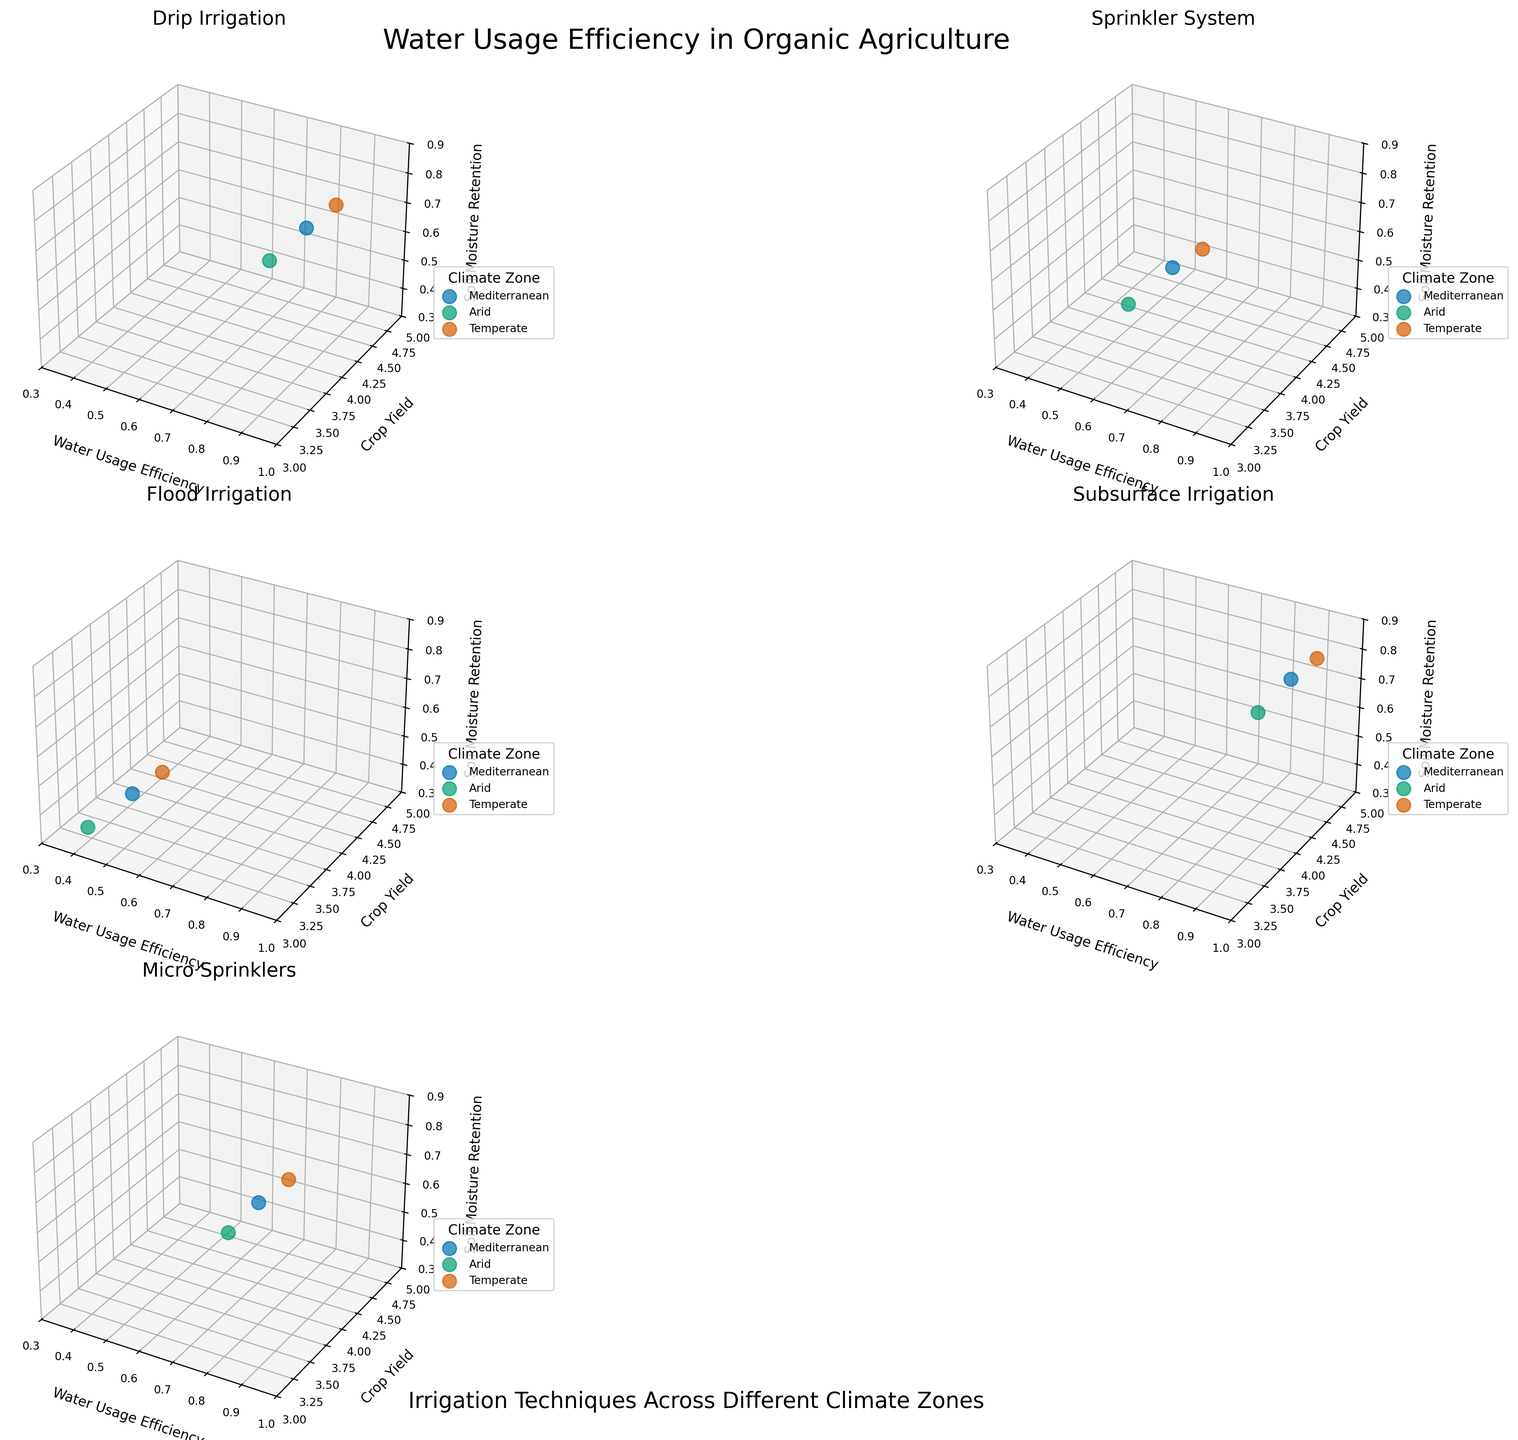What is the title of the overall plot? The overall plot title is positioned at the top-center of the figure and reads "Water Usage Efficiency in Organic Agriculture".
Answer: Water Usage Efficiency in Organic Agriculture Which irrigation technique shows the highest water usage efficiency? By comparing the water usage efficiency values along the x-axis in each subplot, the "Subsurface Irrigation" technique consistently shows the highest values, above 0.85 across all climate zones.
Answer: Subsurface Irrigation How many climate zones are represented in each subplot and what are they? Each subplot includes multiple colored markers, each representing a different climate zone. The legend indicates that the zones are "Mediterranean", "Arid", and "Temperate".
Answer: Three climate zones: Mediterranean, Arid, Temperate For the "Drip Irrigation" technique, which climate zone has the highest soil moisture retention? In the "Drip Irrigation" subplot, soil moisture retention values are indicated along the z-axis. The highest values are observed in the "Temperate" zone (0.75).
Answer: Temperate Compare the crop yield in the "Flood Irrigation" subplot across all climate zones. Which zone has the lowest value? The crop yields for "Flood Irrigation" are indicated along the y-axis. The "Arid" climate zone shows the lowest value with a yield of about 3.2.
Answer: Arid Which irrigation technique has the lowest water usage efficiency in the "Arid" climate zone? By examining the "Arid" points across all subplots, "Flood Irrigation" has the lowest water usage efficiency, with a value of around 0.40.
Answer: Flood Irrigation What differences in crop yield can be observed between "Drip Irrigation" and "Sprinkler System" in the "Temperate" climate zone? The "Drip Irrigation" subplot for the "Temperate" zone shows a crop yield of about 4.5, whereas the "Sprinkler System" subplot shows a yield of about 4.1, indicating a difference of 0.4.
Answer: 0.4 higher in Drip Irrigation For "Micro Sprinklers", what is the relationship between water usage efficiency and soil moisture retention in the "Mediterranean" climate zone? Observing the "Micro Sprinklers" subplot, the "Mediterranean" markers show that as water usage efficiency increases (approximately 0.75), soil moisture retention also increases (approximately 0.65).
Answer: Positive relationship Which irrigation technique demonstrates the highest range in water usage efficiency across all climate zones? By comparing the spread of water usage efficiency values along the x-axis in each subplot, "Flood Irrigation" illustrates the widest range, from 0.40 to 0.50.
Answer: Flood Irrigation Considering the "Subsurface Irrigation" technique, how do the soil moisture retention values differ between the "Mediterranean" and "Arid" zones? The "Subsurface Irrigation" subplot shows soil moisture retention values are 0.78 for "Mediterranean" and 0.74 for "Arid", leading to a difference of 0.04.
Answer: 0.04 higher in Mediterranean 